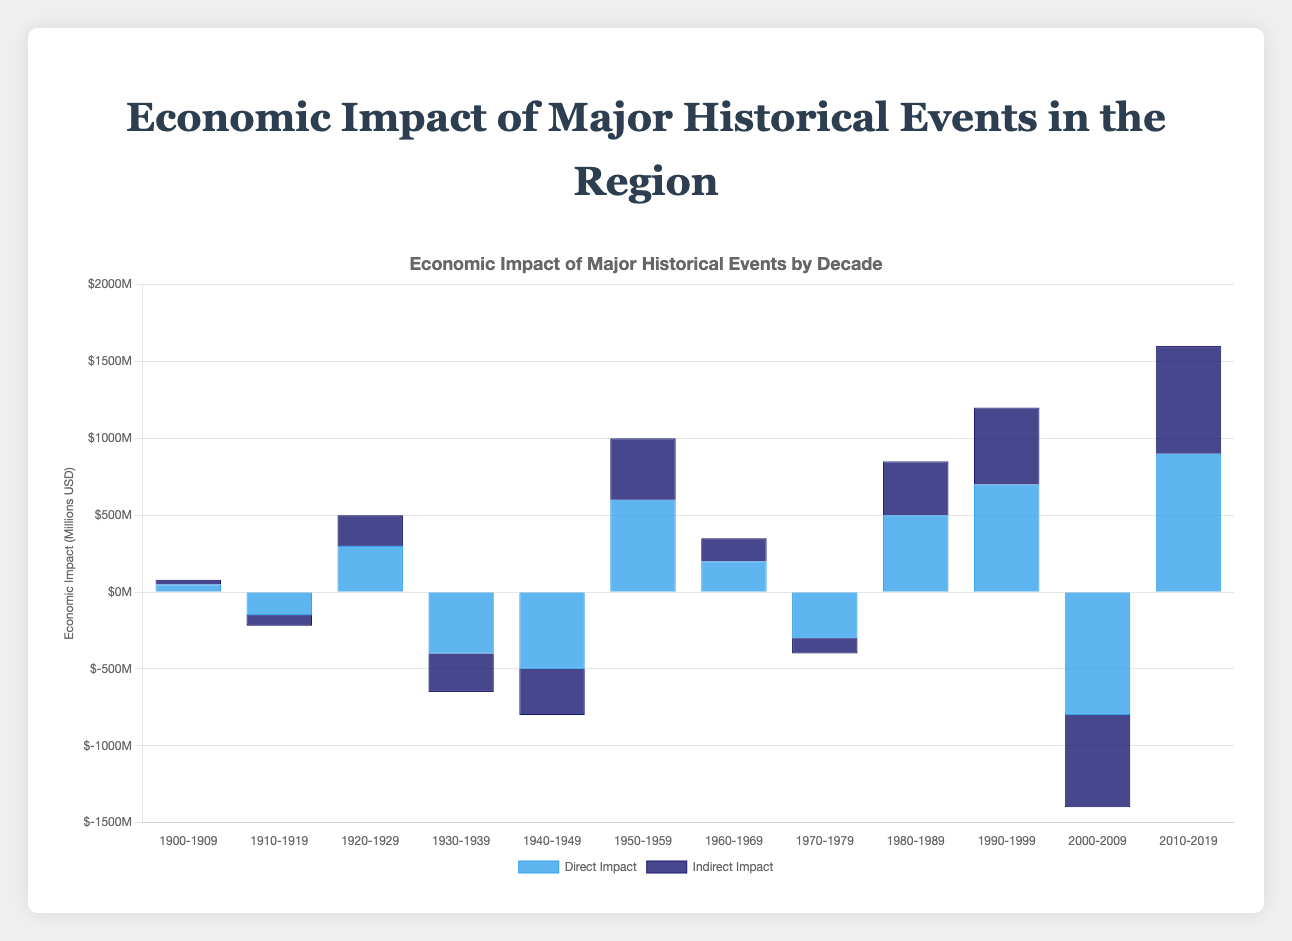Which decade had the highest positive direct economic impact? By visually inspecting the bar chart, the tallest blue bar representing the direct economic impact is in the 2010-2019 decade.
Answer: 2010-2019 Which historical event led to the largest overall negative economic impact in terms of direct and indirect impact combined? Adding the direct and indirect impacts for each event, the largest negative combined impact is from the Global Financial Crisis in 2000-2009, with direct impact (-800) + indirect impact (-600) = -1400 million USD.
Answer: Global Financial Crisis During which decade did indirect impacts exceed direct impacts and by how much? Comparing the heights of the dark blue bars (indirect impact) to the blue bars (direct impact), the 1970-1979 decade (Oil Crisis) had indirect impacts (-100) exceeding direct impacts (-300). The indirect impact falls short of the direct by 200 million USD.
Answer: 1970-1979, by 200 million USD What is the difference between the total economic impact (direct + indirect) of the Roaring Twenties Economic Boom and the Great Depression? The total economic impact for the Roaring Twenties (1920-1929) is direct impact (300) + indirect impact (200) = 500 million USD. The total economic impact for the Great Depression (1930-1939) is direct impact (-400) + indirect impact (-250) = -650 million USD. The difference is 500 - (-650) = 1150 million USD.
Answer: 1150 million USD Compare the direct economic impacts of World War II and the Post-War Economic Recovery. Which had a greater positive or negative impact? World War II (1940-1949) had a direct impact of -500 million USD (negative), while the Post-War Economic Recovery (1950-1959) had a direct impact of 600 million USD (positive). Therefore, the Post-War Economic Recovery had a greater positive impact.
Answer: Post-War Economic Recovery In what decade did an event cause an economic downturn with both direct and indirect impacts being negative? Analyzing the chart, historical events such as World War I (1910-1919), the Great Depression (1930-1939), and the Global Financial Crisis (2000-2009) show negative economic impacts in both direct and indirect facets. The Global Financial Crisis had the most substantial negative impact, with significant height differences indicating severe downturns.
Answer: 2000-2009 Calculate the total economic impact of the Technological Revolution era in the 1980-1989 decade. Summing up the direct (500 million USD) and indirect impacts (350 million USD) of the Technological Revolution gives a total impact of 500 + 350 = 850 million USD.
Answer: 850 million USD Which historical event resulted in approximately equal values for direct and indirect economic impacts? The Roaring Twenties Economic Boom (1920-1929) shows bars that are similar in height, indicating close values of direct (300 million USD) and indirect (200 million USD) impacts.
Answer: Roaring Twenties Economic Boom Identify the event and decade that had the closest overall impact (sum of direct and indirect impacts) to 0. Checking the sum of direct and indirect impacts for each, the Oil Crisis (1970-1979) had direct (-300 million USD) and indirect impacts (-100 million USD), totaling -400 million USD, which is the closest to 0 compared to other decades.
Answer: Oil Crisis 